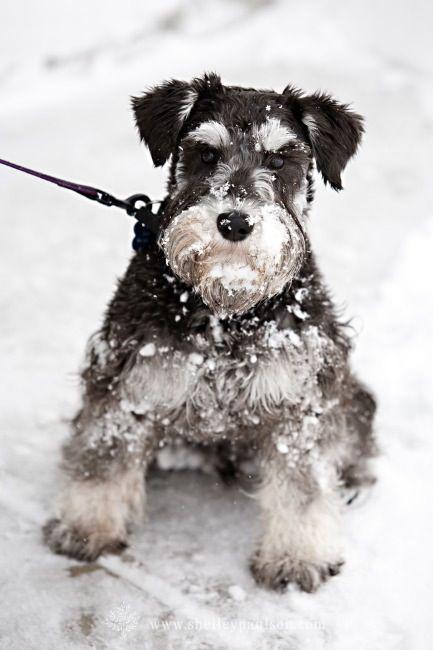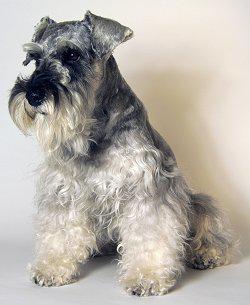The first image is the image on the left, the second image is the image on the right. For the images shown, is this caption "The right image shows a schnauzer standing in the snow." true? Answer yes or no. No. 